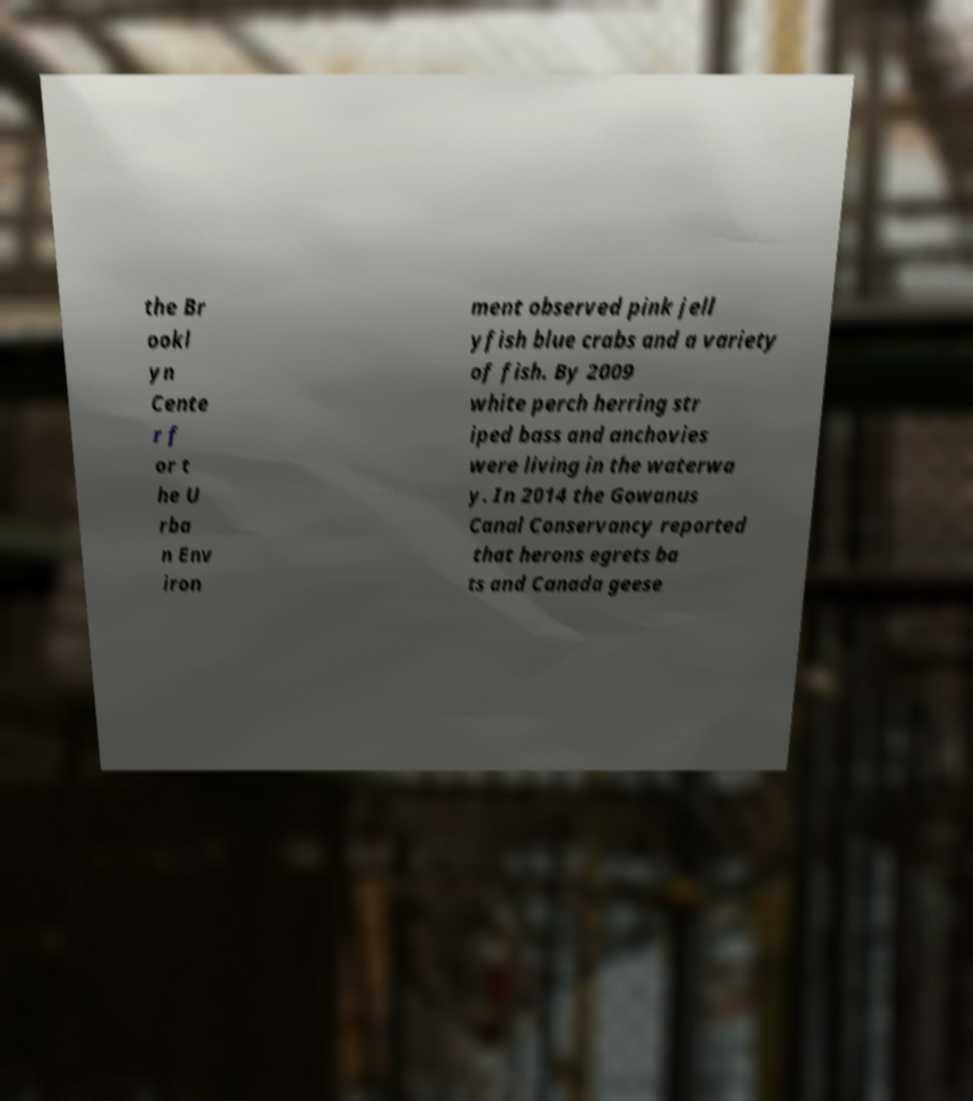Can you accurately transcribe the text from the provided image for me? the Br ookl yn Cente r f or t he U rba n Env iron ment observed pink jell yfish blue crabs and a variety of fish. By 2009 white perch herring str iped bass and anchovies were living in the waterwa y. In 2014 the Gowanus Canal Conservancy reported that herons egrets ba ts and Canada geese 